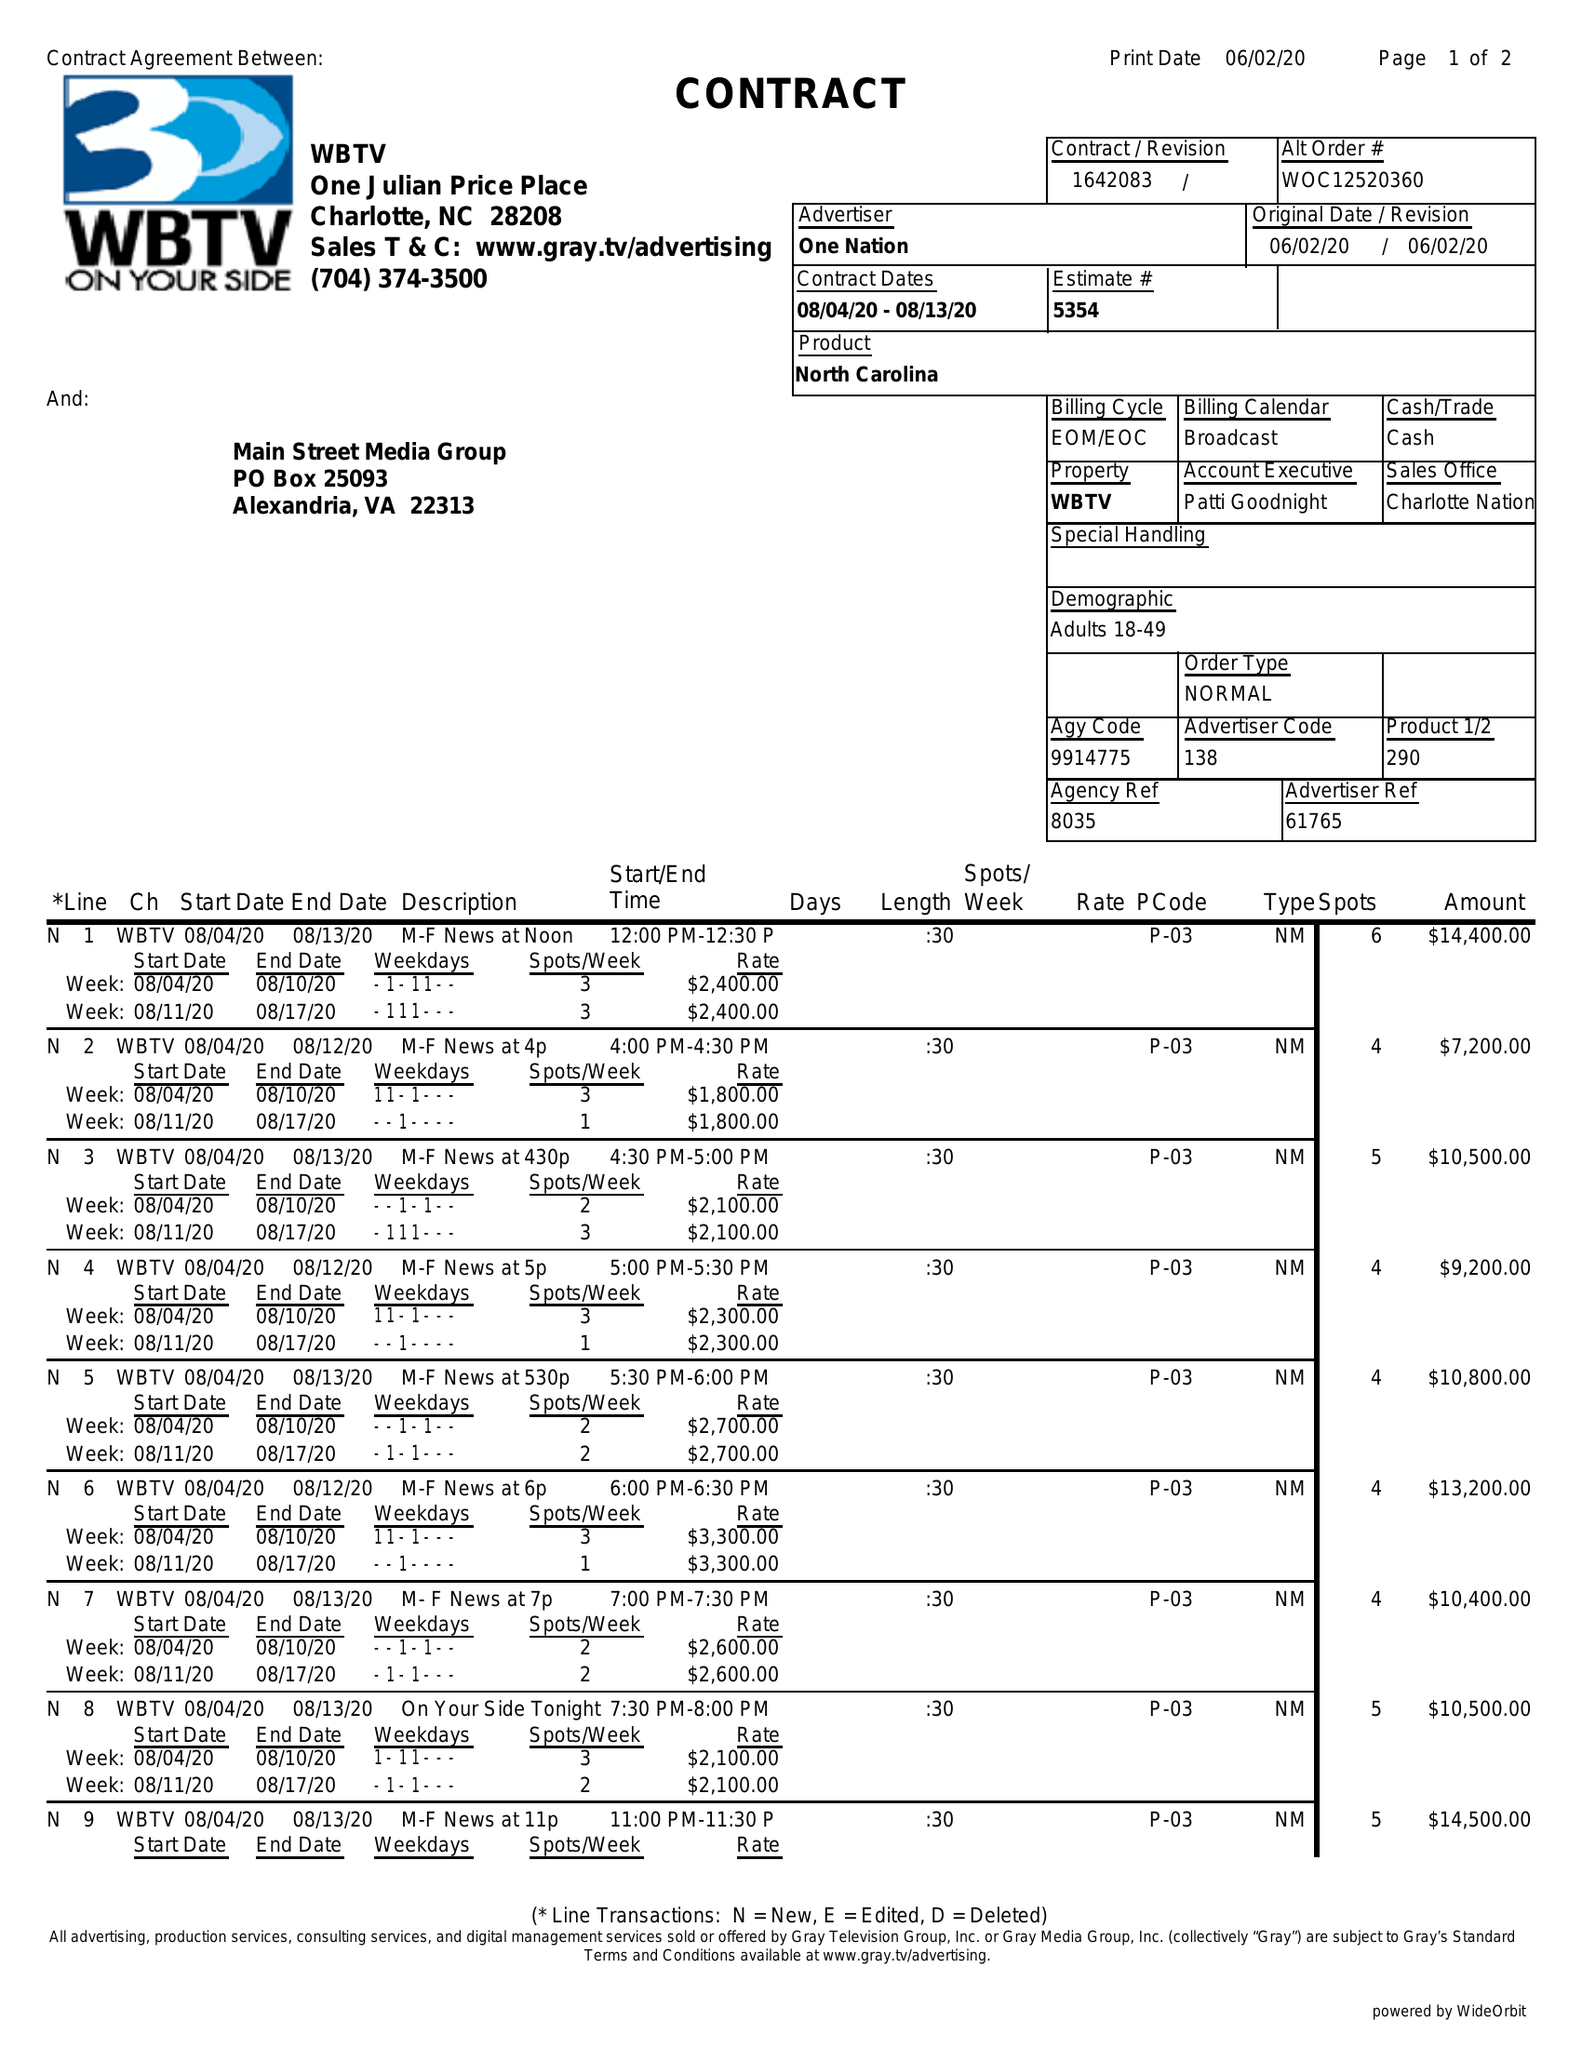What is the value for the flight_to?
Answer the question using a single word or phrase. 08/13/20 